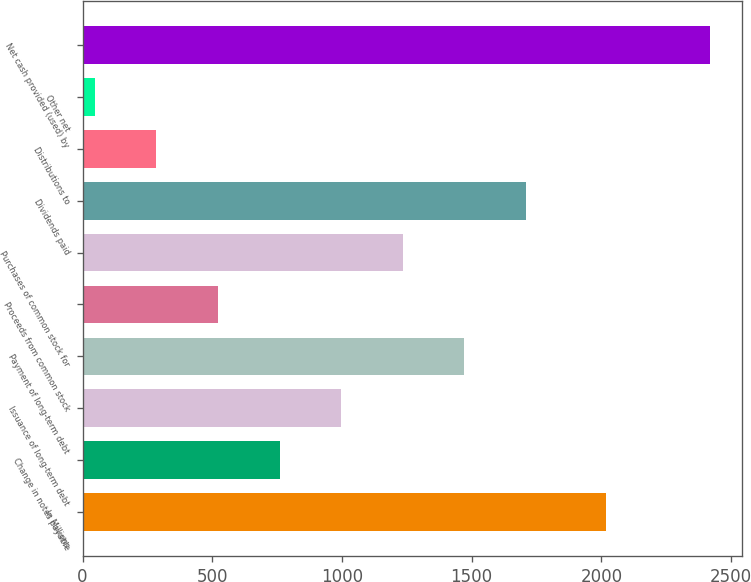Convert chart. <chart><loc_0><loc_0><loc_500><loc_500><bar_chart><fcel>In Millions<fcel>Change in notes payable<fcel>Issuance of long-term debt<fcel>Payment of long-term debt<fcel>Proceeds from common stock<fcel>Purchases of common stock for<fcel>Dividends paid<fcel>Distributions to<fcel>Other net<fcel>Net cash provided (used) by<nl><fcel>2016<fcel>759.25<fcel>996.5<fcel>1471<fcel>522<fcel>1233.75<fcel>1708.25<fcel>284.75<fcel>47.5<fcel>2420<nl></chart> 